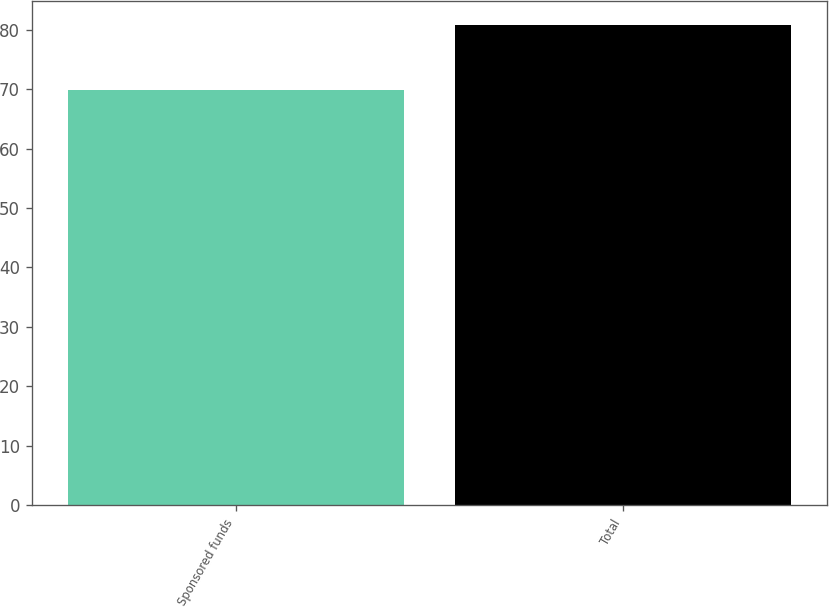Convert chart. <chart><loc_0><loc_0><loc_500><loc_500><bar_chart><fcel>Sponsored funds<fcel>Total<nl><fcel>69.8<fcel>80.7<nl></chart> 